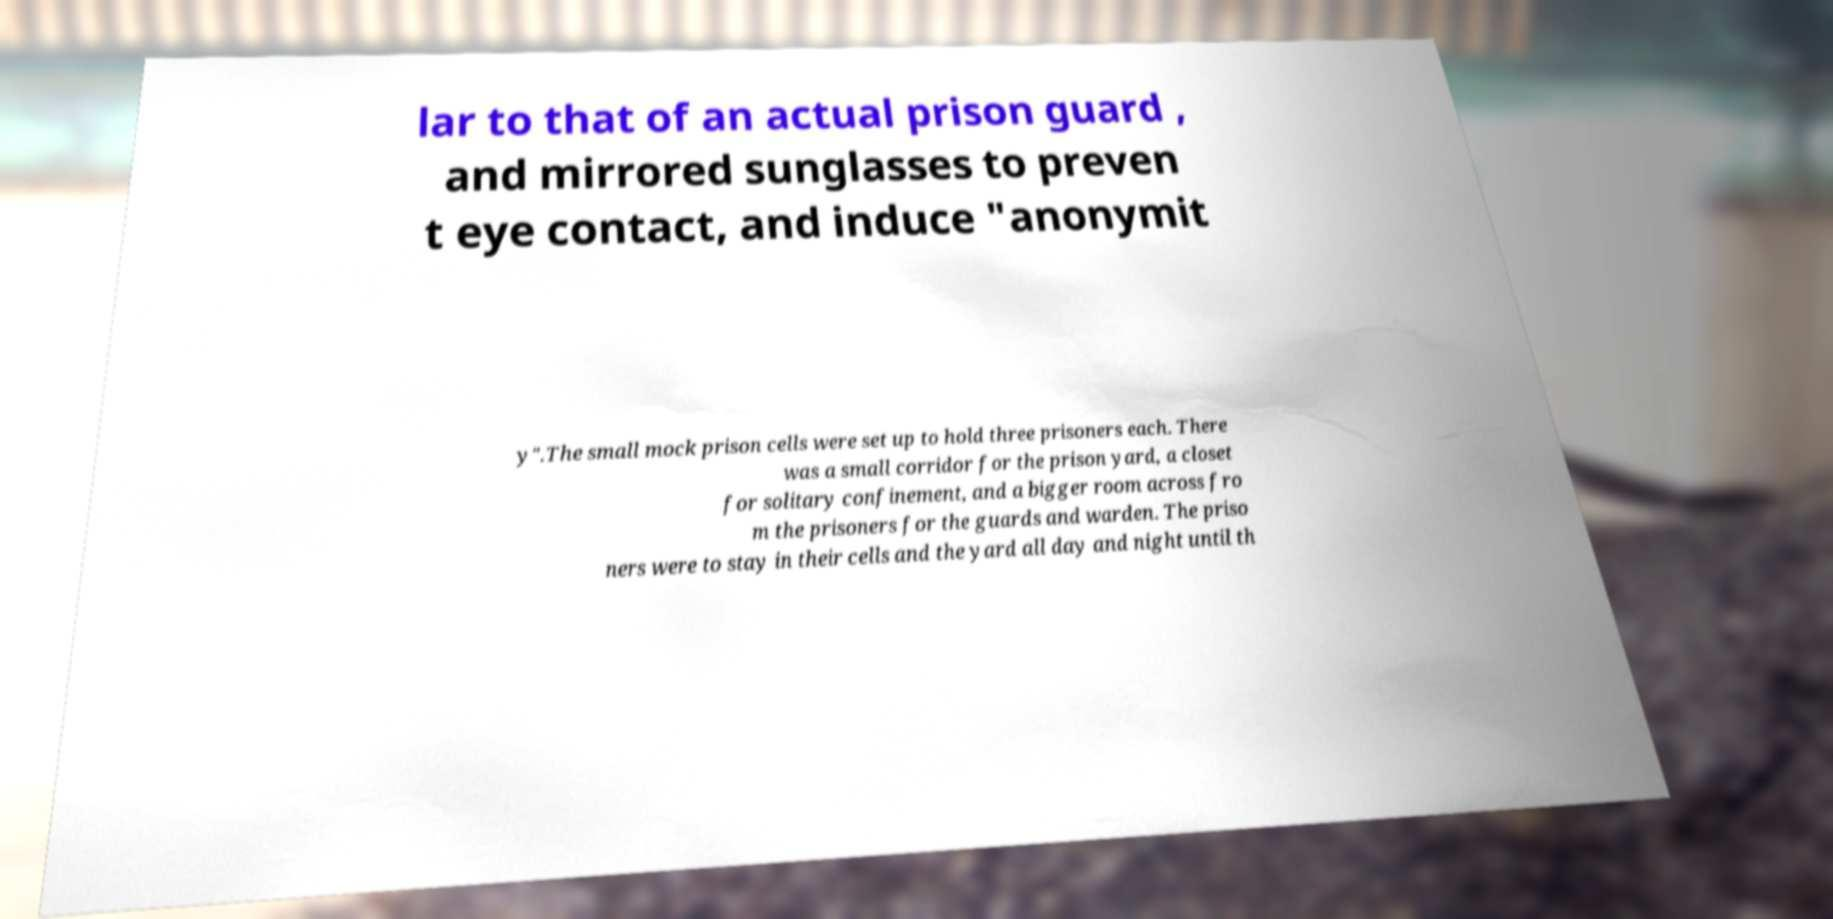For documentation purposes, I need the text within this image transcribed. Could you provide that? lar to that of an actual prison guard , and mirrored sunglasses to preven t eye contact, and induce "anonymit y".The small mock prison cells were set up to hold three prisoners each. There was a small corridor for the prison yard, a closet for solitary confinement, and a bigger room across fro m the prisoners for the guards and warden. The priso ners were to stay in their cells and the yard all day and night until th 